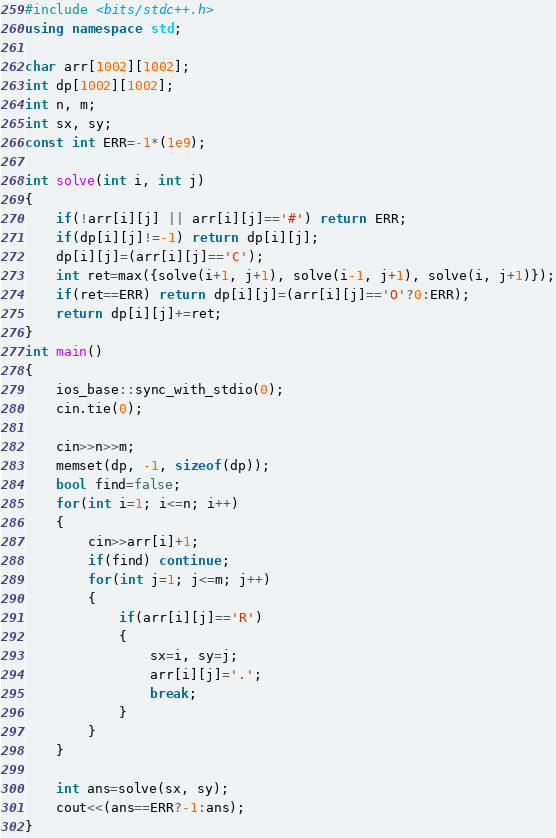Convert code to text. <code><loc_0><loc_0><loc_500><loc_500><_C++_>#include <bits/stdc++.h>
using namespace std;

char arr[1002][1002];
int dp[1002][1002];
int n, m;
int sx, sy;
const int ERR=-1*(1e9);

int solve(int i, int j)
{
    if(!arr[i][j] || arr[i][j]=='#') return ERR;
    if(dp[i][j]!=-1) return dp[i][j];
    dp[i][j]=(arr[i][j]=='C');
    int ret=max({solve(i+1, j+1), solve(i-1, j+1), solve(i, j+1)});
    if(ret==ERR) return dp[i][j]=(arr[i][j]=='O'?0:ERR);
    return dp[i][j]+=ret;
}
int main()
{
    ios_base::sync_with_stdio(0);
    cin.tie(0);

    cin>>n>>m;
    memset(dp, -1, sizeof(dp));
    bool find=false;
    for(int i=1; i<=n; i++)
    {
        cin>>arr[i]+1;
        if(find) continue;
        for(int j=1; j<=m; j++)
        {
            if(arr[i][j]=='R')
            {
                sx=i, sy=j;
                arr[i][j]='.';
                break;
            }
        }
    }

    int ans=solve(sx, sy);
    cout<<(ans==ERR?-1:ans);
}</code> 